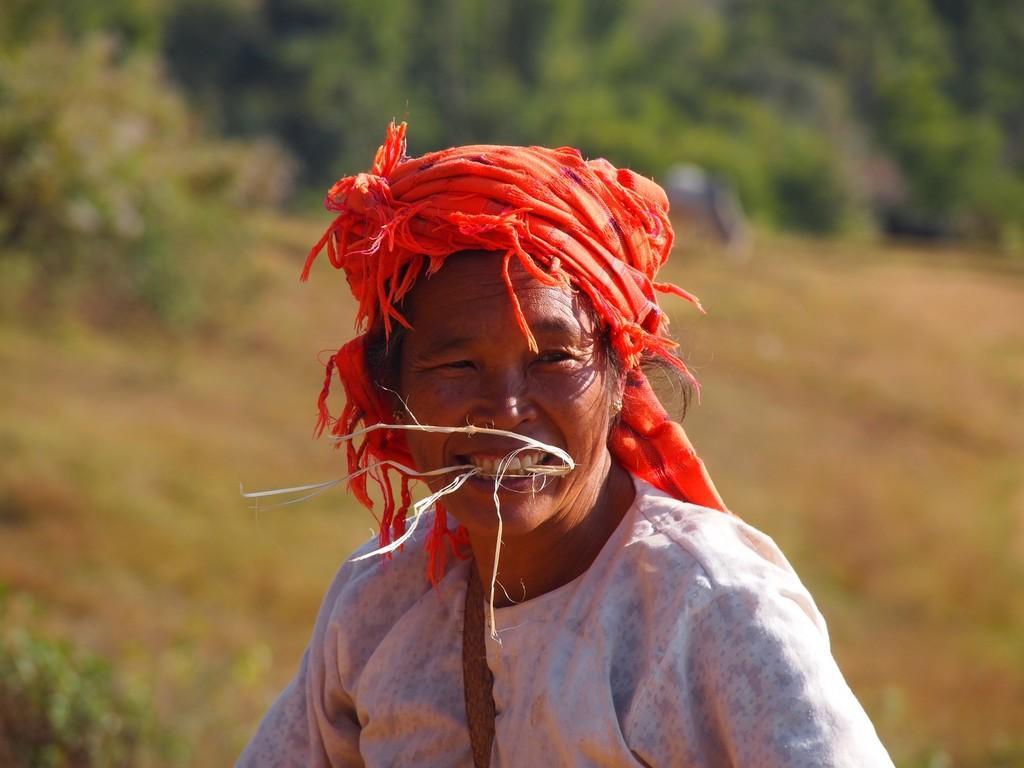How would you summarize this image in a sentence or two? In this picture we can see a person and in the background we can see trees and it is blurry. 